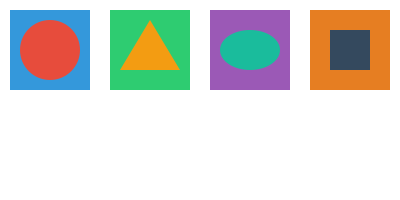En el conjunto de íconos de aplicaciones mostrado, ¿cuál de ellos presenta un defecto visual evidente que podría indicar un problema de resolución o renderizado? Para identificar un defecto visual en los íconos de aplicaciones, debemos examinar cada uno cuidadosamente:

1. Primer ícono (izquierda): Un cuadrado azul con un círculo rojo superpuesto. Los bordes son nítidos y la superposición es correcta.

2. Segundo ícono: Un cuadrado verde con un triángulo amarillo superpuesto. Los bordes son nítidos y la forma es precisa.

3. Tercer ícono: Un cuadrado púrpura con una elipse verde claro superpuesto. Los bordes son nítidos y la elipse está correctamente centrada.

4. Cuarto ícono (derecha): Un cuadrado naranja con un cuadrado más pequeño gris oscuro superpuesto. Aquí es donde notamos un problema: el cuadrado interior tiene bordes irregulares o pixelados, lo que indica un problema de resolución o renderizado.

El cuarto ícono muestra claramente un defecto visual en forma de bordes pixelados o irregulares en la forma interior, lo que no es consistente con la nitidez de los otros íconos y sugiere un problema de resolución o renderizado.
Answer: El cuarto ícono (derecha) 